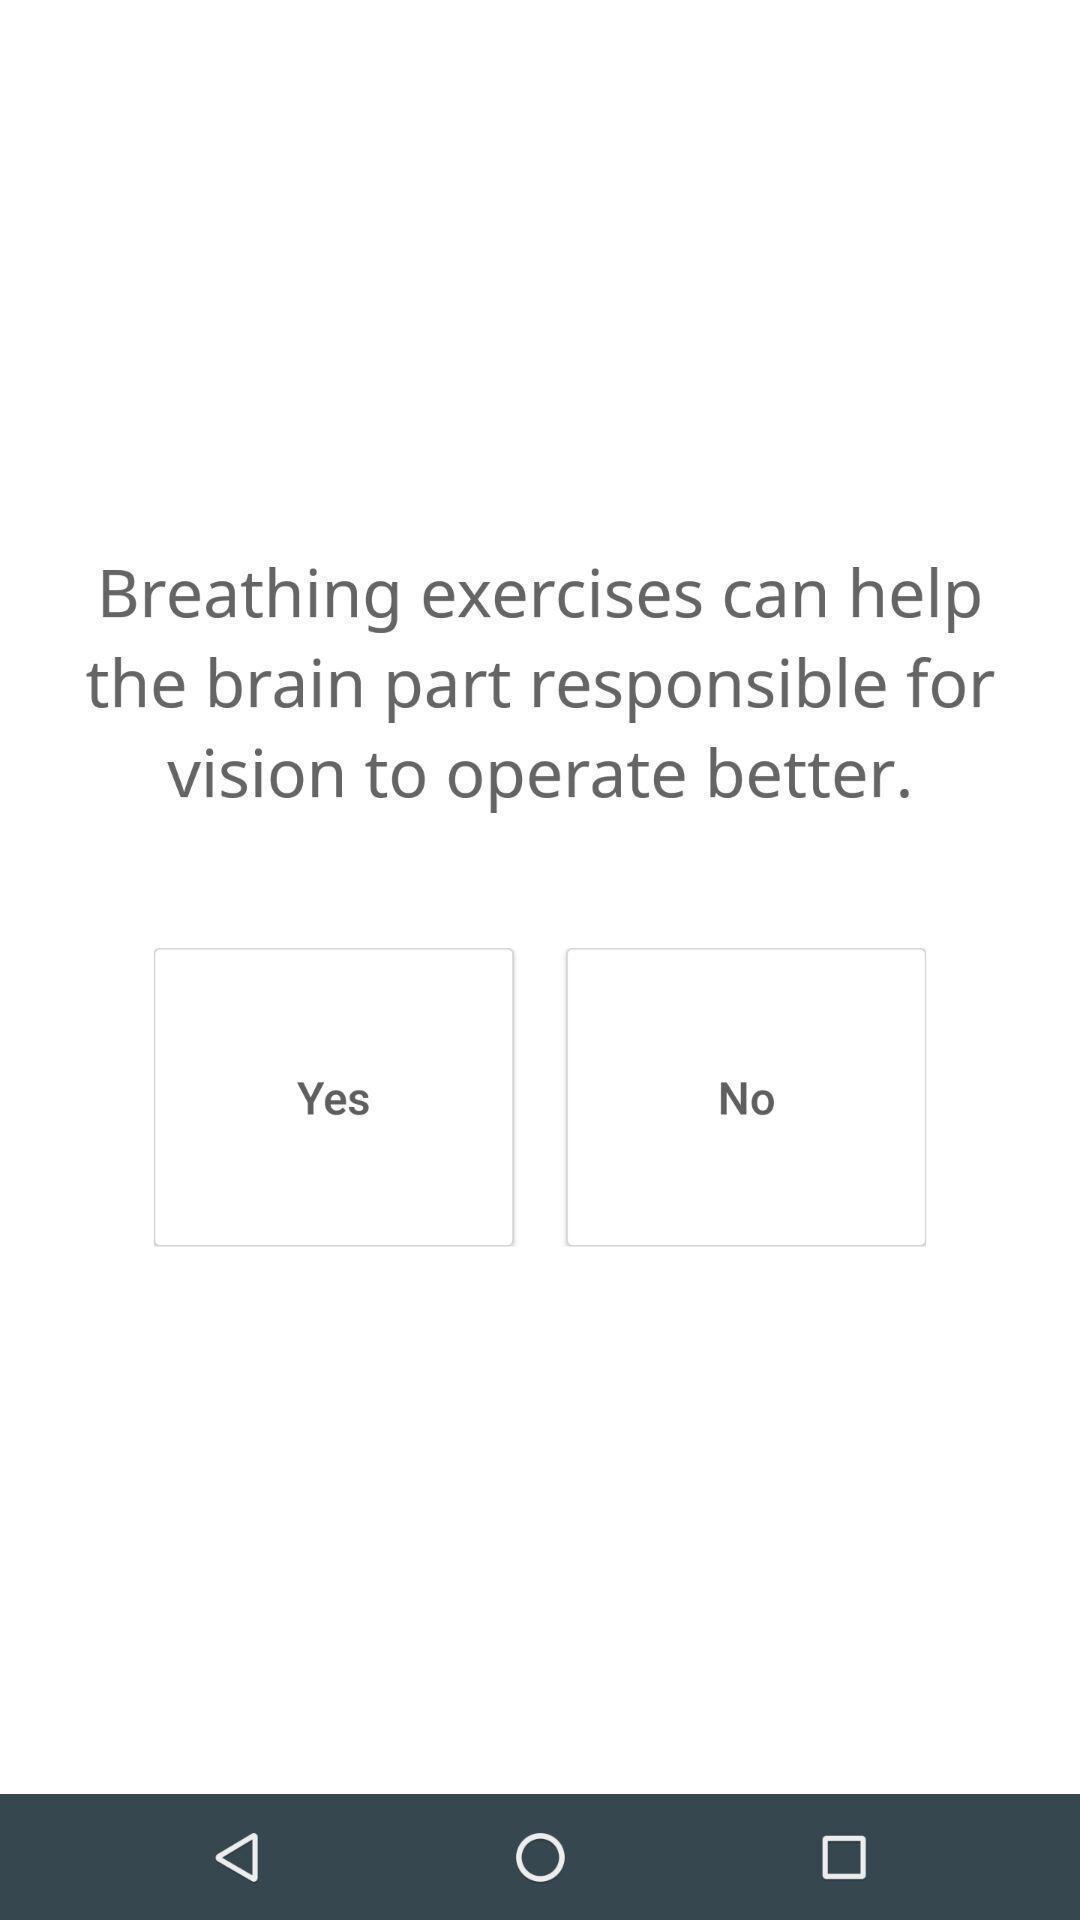Give me a narrative description of this picture. Text alert in the application regarding breathing exercise. 